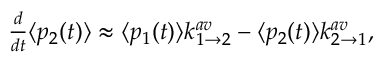Convert formula to latex. <formula><loc_0><loc_0><loc_500><loc_500>\begin{array} { r } { \frac { d } { d t } \langle p _ { 2 } ( t ) \rangle \approx \langle p _ { 1 } ( t ) \rangle k _ { 1 \rightarrow 2 } ^ { a v } - \langle p _ { 2 } ( t ) \rangle k _ { 2 \rightarrow 1 } ^ { a v } , } \end{array}</formula> 